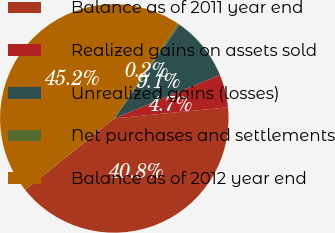<chart> <loc_0><loc_0><loc_500><loc_500><pie_chart><fcel>Balance as of 2011 year end<fcel>Realized gains on assets sold<fcel>Unrealized gains (losses)<fcel>Net purchases and settlements<fcel>Balance as of 2012 year end<nl><fcel>40.78%<fcel>4.67%<fcel>9.11%<fcel>0.24%<fcel>45.21%<nl></chart> 